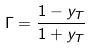<formula> <loc_0><loc_0><loc_500><loc_500>\Gamma = \frac { 1 - y _ { T } } { 1 + y _ { T } }</formula> 